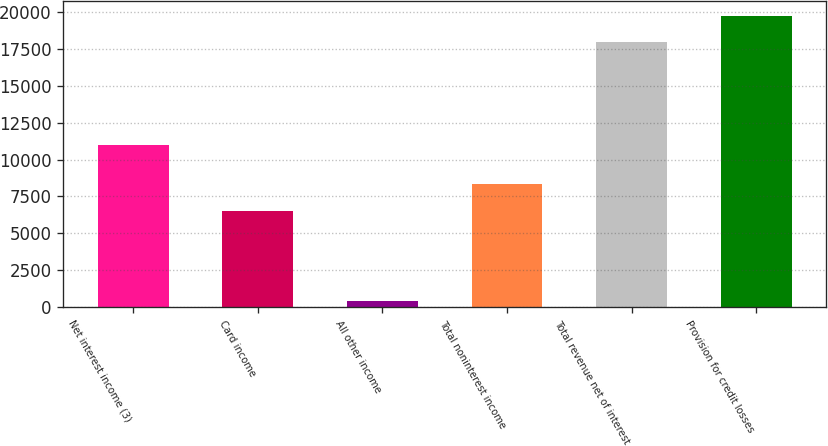Convert chart. <chart><loc_0><loc_0><loc_500><loc_500><bar_chart><fcel>Net interest income (3)<fcel>Card income<fcel>All other income<fcel>Total noninterest income<fcel>Total revenue net of interest<fcel>Provision for credit losses<nl><fcel>11014<fcel>6521<fcel>408<fcel>8348.4<fcel>17943<fcel>19770.4<nl></chart> 